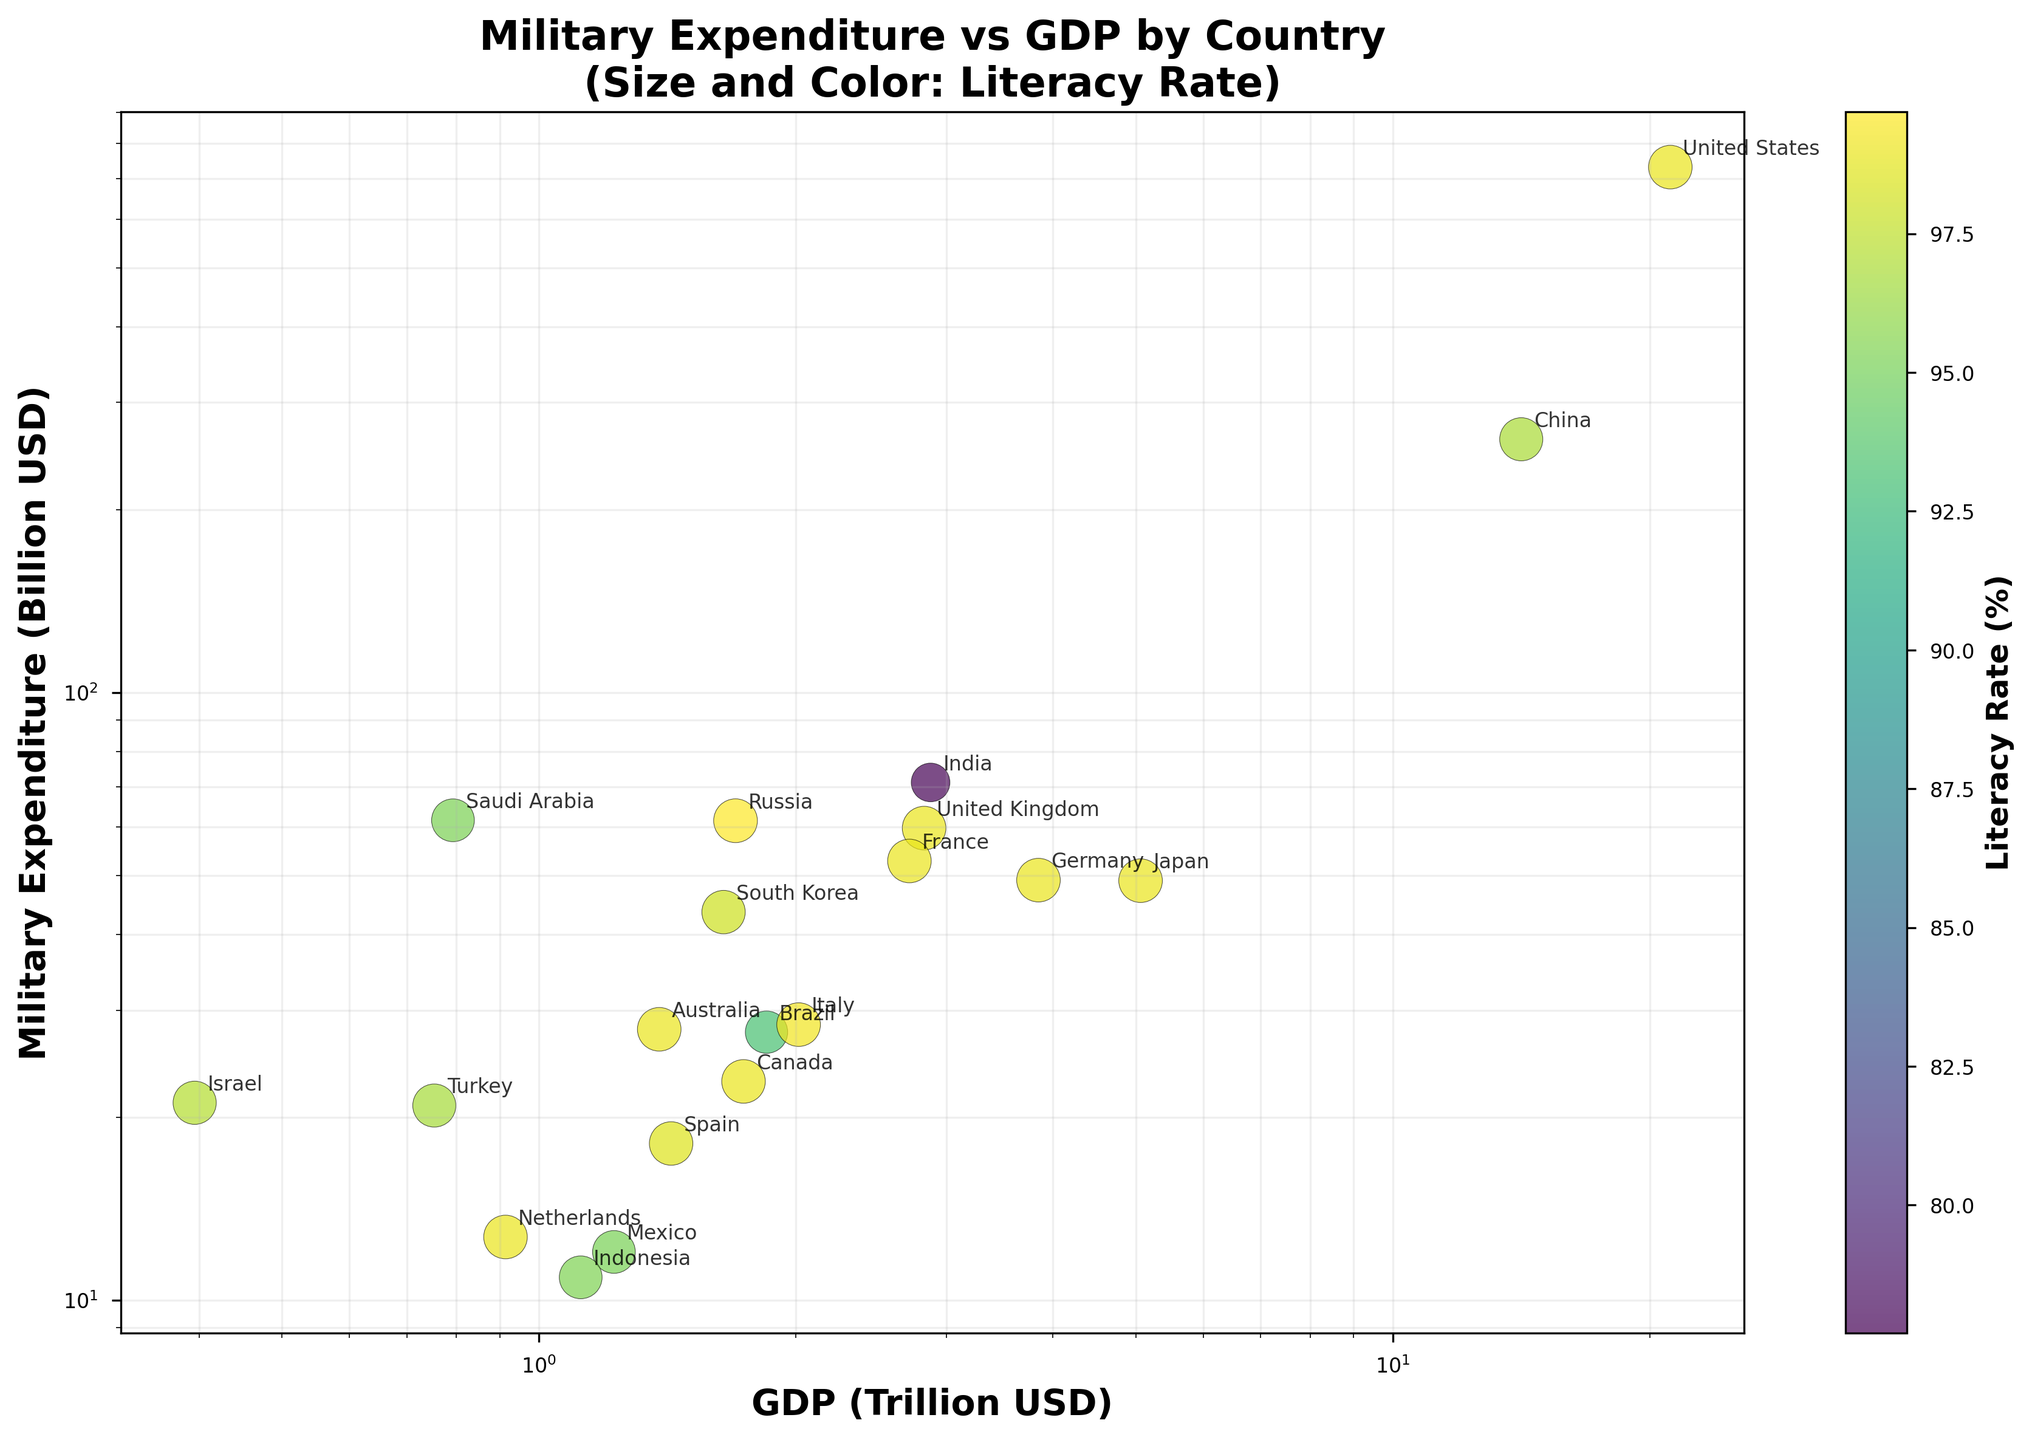What's the title of the figure? The title of any figure is typically found at the top and is a concise statement that summarizes what the figure portrays. The title here is "Military Expenditure vs GDP by Country\n(Size and Color: Literacy Rate)".
Answer: Military Expenditure vs GDP by Country (Size and Color: Literacy Rate) What does the x-axis represent? The x-axis label is typically placed along the horizontal axis and describes what is being measured. Here, it is "GDP (Trillion USD)".
Answer: GDP (Trillion USD) What does the y-axis represent? The y-axis label is usually located along the vertical axis and indicates what data is being measured. Here, it is "Military Expenditure (Billion USD)".
Answer: Military Expenditure (Billion USD) How many countries are plotted in the figure? Each dot in a scatter plot represents one country, and the countries are labeled next to their respective dots. Counting the labels, we see there are 20 countries plotted.
Answer: 20 Which country has the highest military expenditure? By identifying the highest point on the y-axis and checking the corresponding label, we see that the United States has the highest military expenditure.
Answer: United States Which country has the lowest literacy rate? By observing the colors corresponding to literacy rates in the scatter plot and checking against the color bar, the country with the darkest color (indicating the lowest rate) is India.
Answer: India Do countries with higher GDP tend to have higher military expenditures? By examining the scatter plot as a whole, we observe that countries with higher GDP (towards the right) generally also have higher military expenditures (towards the top), indicating a trend.
Answer: Yes Compare the literacy rates of Russia and Saudi Arabia. Which is higher? By comparing the colors of these two countries' dots against the color bar, Russia (lighter color) has a higher literacy rate compared to Saudi Arabia (darker color).
Answer: Russia What is the literacy rate range for the countries plotted? By examining the color bar, which indicates the range of literacy rates, we see that the literacy rates vary from around 77% to 99.7%.
Answer: 77% to 99.7% How does the GDP of Germany compare to that of Canada? By locating Germany and Canada on the x-axis and comparing their positions, we see Germany (further right) has a higher GDP than Canada.
Answer: Germany has a higher GDP 